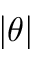Convert formula to latex. <formula><loc_0><loc_0><loc_500><loc_500>| \theta |</formula> 